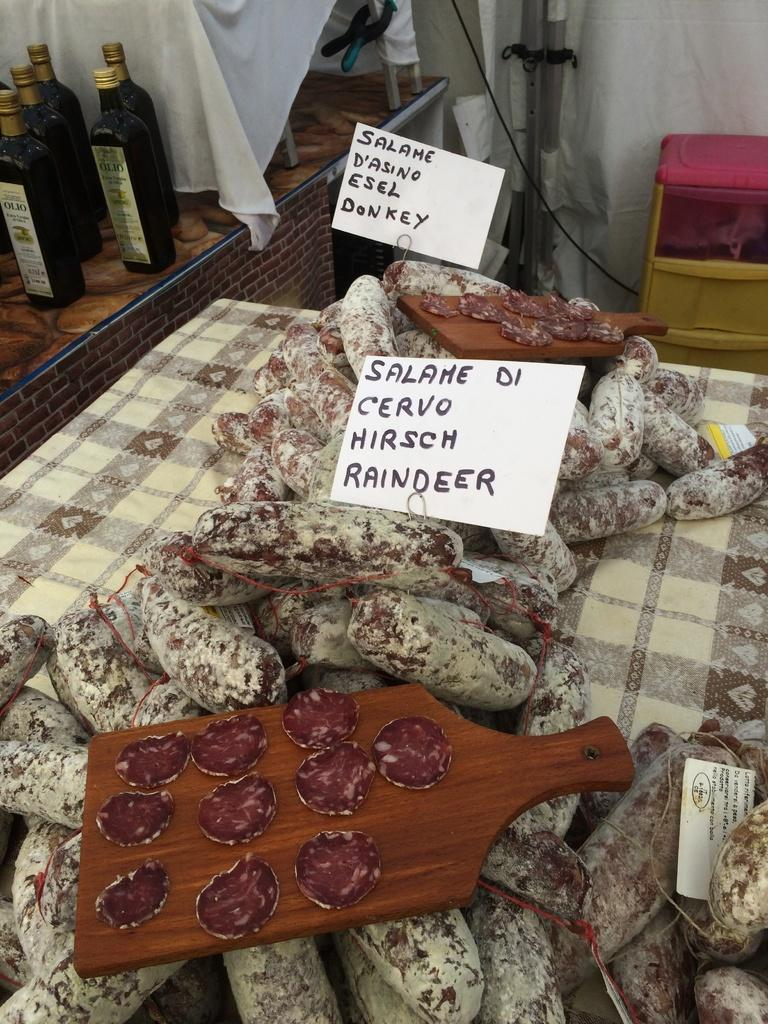<image>
Describe the image concisely. Sliced meat is on a cutting board with a sign that says salame cervo hirsch Raindeer. 